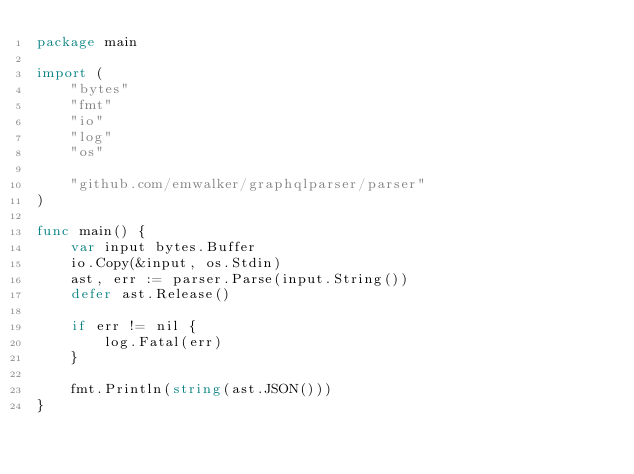<code> <loc_0><loc_0><loc_500><loc_500><_Go_>package main

import (
	"bytes"
	"fmt"
	"io"
	"log"
	"os"

	"github.com/emwalker/graphqlparser/parser"
)

func main() {
	var input bytes.Buffer
	io.Copy(&input, os.Stdin)
	ast, err := parser.Parse(input.String())
	defer ast.Release()

	if err != nil {
		log.Fatal(err)
	}

	fmt.Println(string(ast.JSON()))
}
</code> 